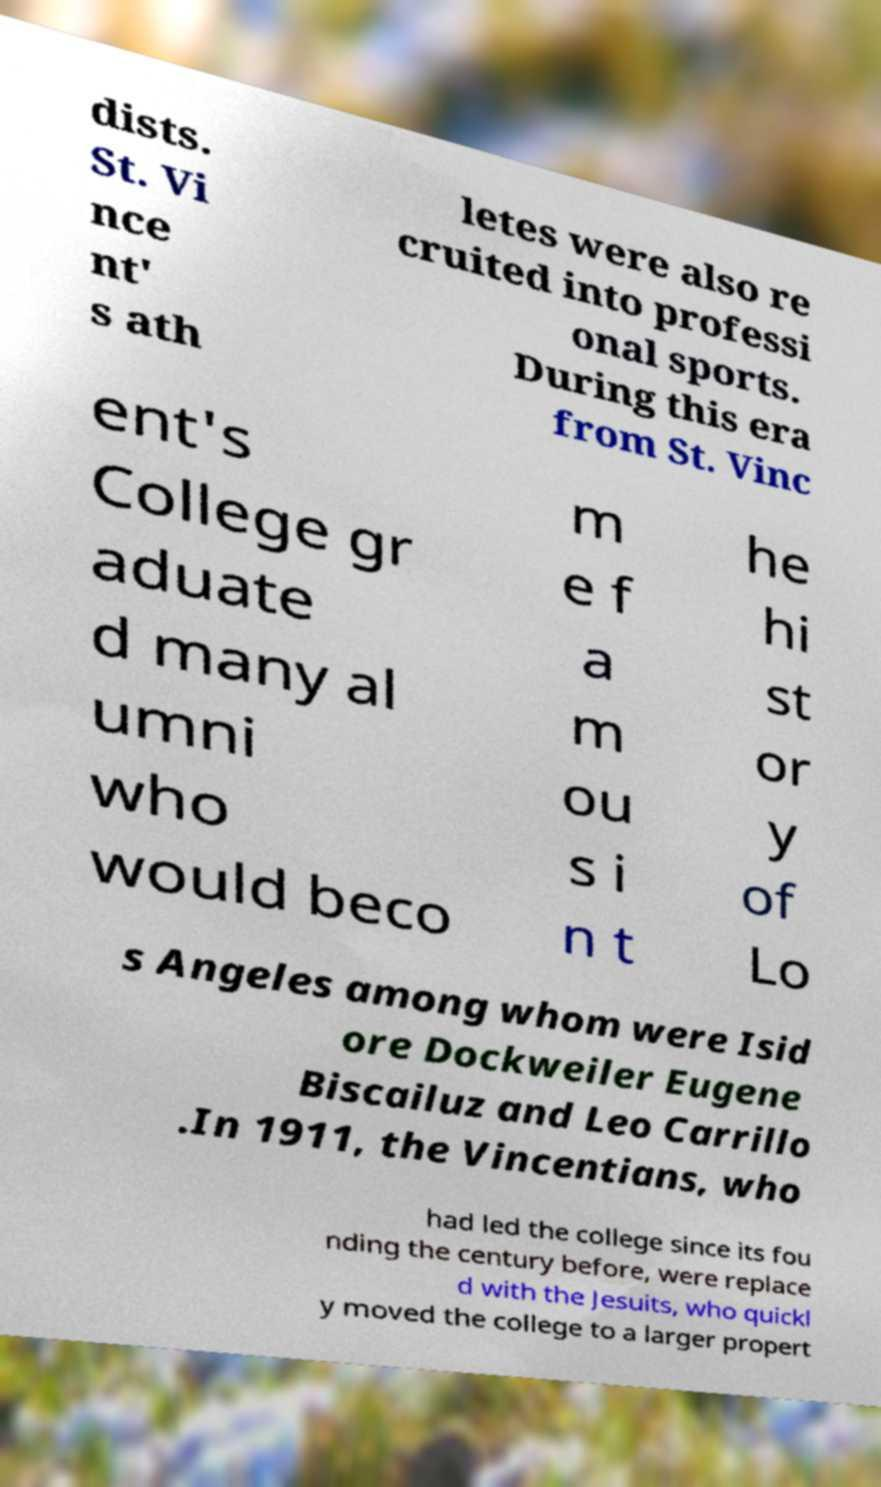Could you extract and type out the text from this image? dists. St. Vi nce nt' s ath letes were also re cruited into professi onal sports. During this era from St. Vinc ent's College gr aduate d many al umni who would beco m e f a m ou s i n t he hi st or y of Lo s Angeles among whom were Isid ore Dockweiler Eugene Biscailuz and Leo Carrillo .In 1911, the Vincentians, who had led the college since its fou nding the century before, were replace d with the Jesuits, who quickl y moved the college to a larger propert 